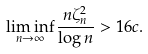Convert formula to latex. <formula><loc_0><loc_0><loc_500><loc_500>\liminf _ { n \to \infty } \frac { n \zeta _ { n } ^ { 2 } } { \log n } > 1 6 c .</formula> 